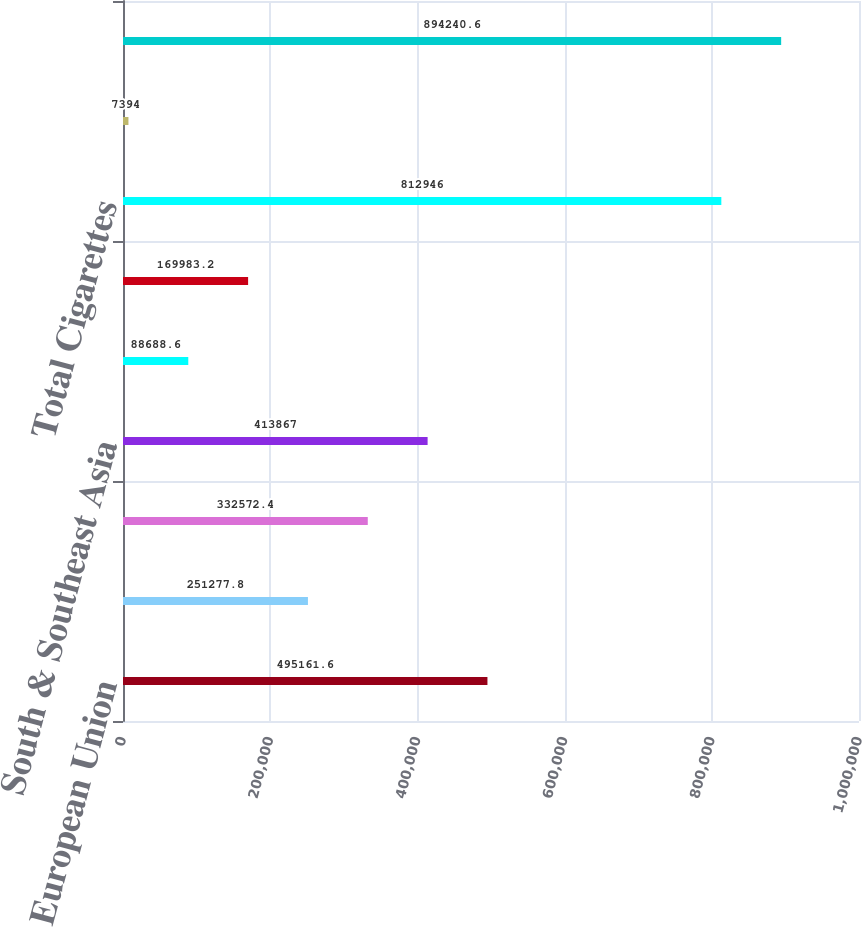Convert chart. <chart><loc_0><loc_0><loc_500><loc_500><bar_chart><fcel>European Union<fcel>Eastern Europe<fcel>Middle East & Africa<fcel>South & Southeast Asia<fcel>East Asia & Australia<fcel>Latin America & Canada<fcel>Total Cigarettes<fcel>Total Heated Tobacco Units<fcel>Total Cigarettes and Heated<nl><fcel>495162<fcel>251278<fcel>332572<fcel>413867<fcel>88688.6<fcel>169983<fcel>812946<fcel>7394<fcel>894241<nl></chart> 